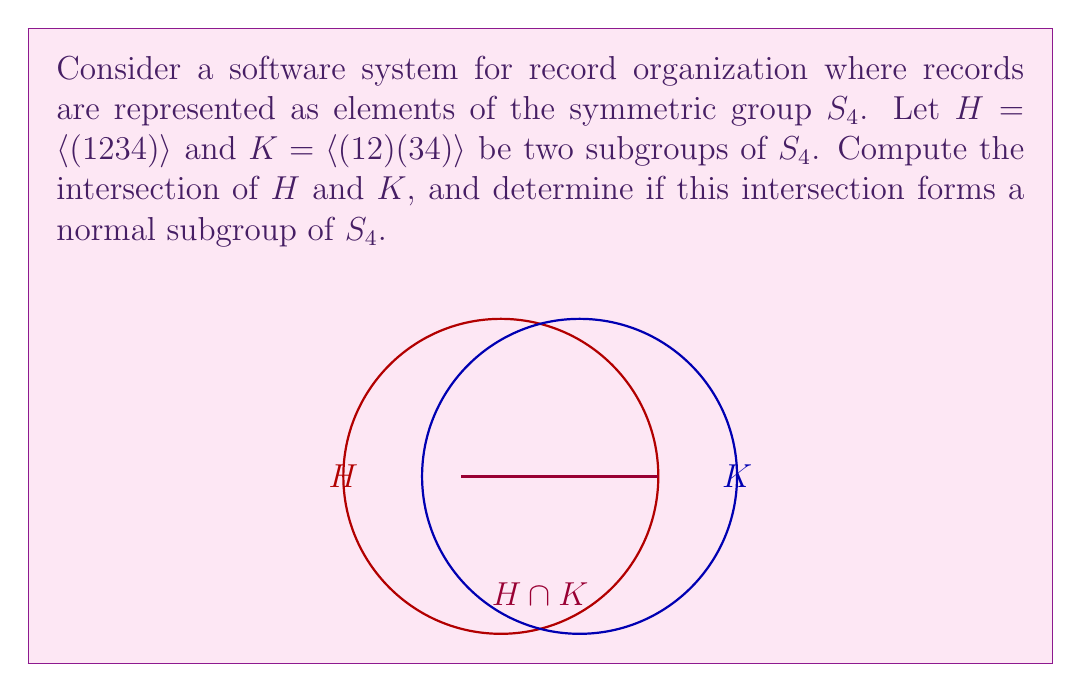Could you help me with this problem? Let's approach this step-by-step:

1) First, let's determine the elements of each subgroup:

   $H = \langle (1234) \rangle = \{e, (1234), (13)(24), (1432)\}$
   $K = \langle (12)(34) \rangle = \{e, (12)(34)\}$

2) To find the intersection $H \cap K$, we need to identify the elements that are in both $H$ and $K$:

   $H \cap K = \{e\}$

   The only element common to both subgroups is the identity element $e$.

3) Now, let's determine if $\{e\}$ is a normal subgroup of $S_4$. A subgroup $N$ is normal in $G$ if $gNg^{-1} = N$ for all $g \in G$.

4) For any $g \in S_4$:
   
   $g\{e\}g^{-1} = \{geg^{-1}\} = \{e\}$

5) This holds for all $g \in S_4$, so $\{e\}$ is indeed a normal subgroup of $S_4$.

In the context of record organization software, this result implies that the identity permutation (which represents no change in record order) is the only operation common to both subgroups, and this operation is invariant under any other permutation in the system.
Answer: $H \cap K = \{e\}$; Yes, it's a normal subgroup of $S_4$. 